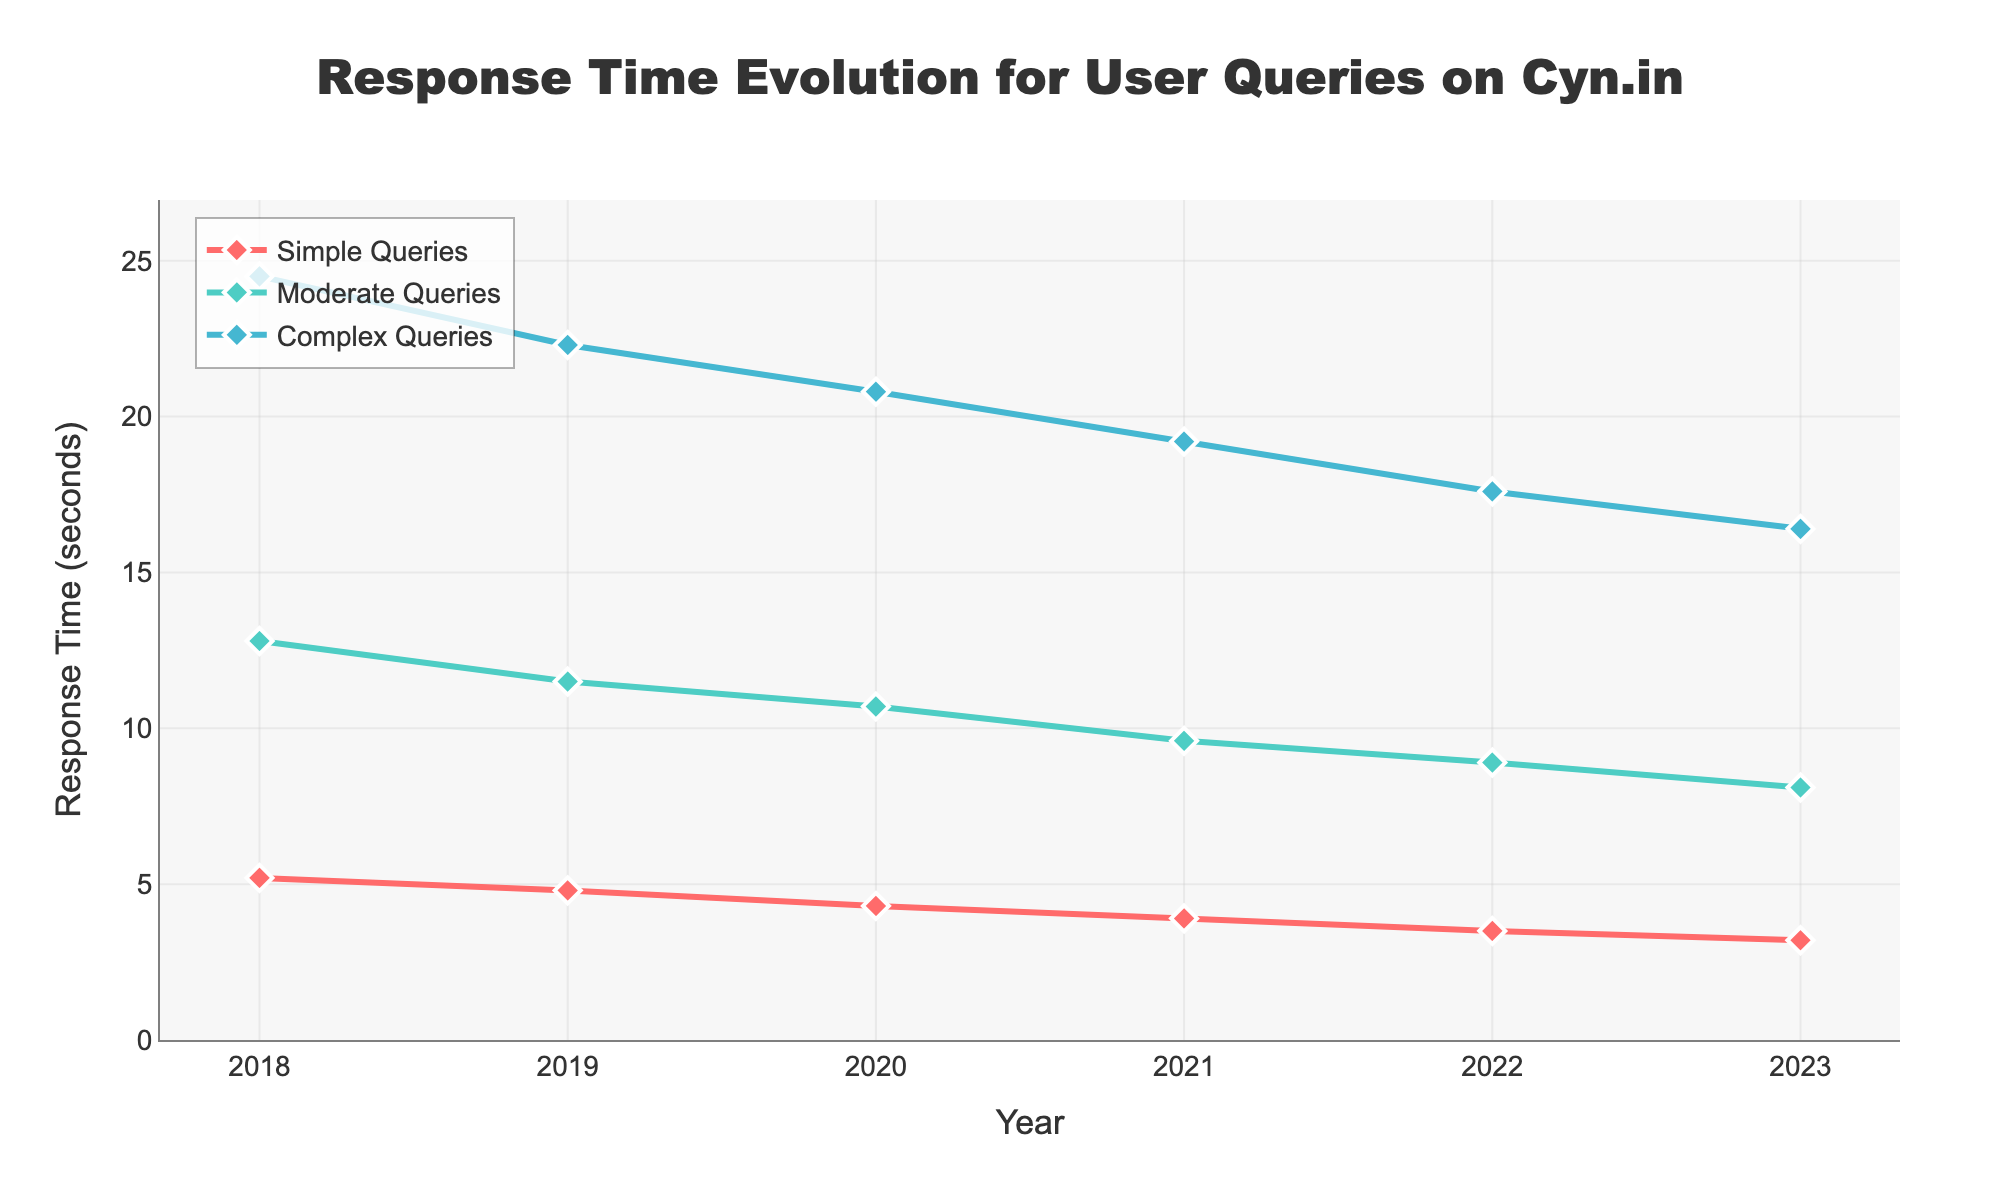What is the trend of response times for simple queries from 2018 to 2023? The response times for simple queries decrease consistently from approximately 5.2 seconds in 2018 to 3.2 seconds in 2023. This indicates an improvement in handling time for simple queries over the years.
Answer: Decreasing What is the percentage decrease in response time for moderate queries from 2018 to 2023? To calculate the percentage decrease: ((12.8 - 8.1) / 12.8) * 100. This gives us ((4.7) / 12.8) * 100 ≈ 36.72%.
Answer: 36.72% How do the response times for complex queries compare between 2018 and 2023? In 2018, the response time for complex queries was 24.5 seconds, whereas in 2023, it is 16.4. Thus, the response time for complex queries has decreased.
Answer: Decrease What is the average response time for moderate queries over the years 2018 and 2023? Average = (Sum of values over years) / number of years. Sum = 12.8 + 11.5 + 10.7 + 9.6 + 8.9 + 8.1 = 61.6; Average = 61.6 / 6 ≈ 10.27.
Answer: 10.27 Which type of query showed the largest absolute improvement in response time from 2018 to 2023? The absolute improvement can be found by subtraction: Simple Queries: 5.2 - 3.2 = 2; Moderate Queries: 12.8 - 8.1 = 4.7; Complex Queries: 24.5 - 16.4 = 8.1. Complex queries showed the largest improvement.
Answer: Complex Queries Between which two consecutive years did simple queries show the greatest reduction in response time? To find the greatest reduction, calculate the difference between consecutive years: (5.2 - 4.8), (4.8 - 4.3), (4.3 - 3.9), (3.9 - 3.5), (3.5 - 3.2): the largest reduction is between 2018 and 2019 with 0.4 seconds.
Answer: 2018 and 2019 What is the difference in response times between moderate and complex queries in 2023? In 2023, the response time for moderate queries is 8.1 seconds, and for complex queries, it is 16.4 seconds. The difference is 16.4 - 8.1 = 8.3 seconds.
Answer: 8.3 seconds Which year exhibits the lowest average response time across all types of queries? Calculate the average response time for each year: 2018: (5.2 + 12.8 + 24.5)/3 = 14.17; 2019: (4.8 + 11.5 + 22.3)/3 = 12.87; 2020: (4.3 + 10.7 + 20.8)/3 = 11.93; 2021: (3.9 + 9.6 + 19.2)/3 = 10.9; 2022: (3.5 + 8.9 + 17.6)/3 = 10; 2023: (3.2 + 8.1 + 16.4)/3 = 9.23. The year 2023 has the lowest average response time at 9.23 seconds.
Answer: 2023 How much has the response time for complex queries improved in total from 2018 to 2023? The improvement can be calculated by subtracting the response time in 2023 from the time in 2018: 24.5 - 16.4 = 8.1.
Answer: 8.1 Which query type had the least year-over-year change in response time between 2020 and 2021? Calculate the year-over-year changes: Simple Queries: 4.3 - 3.9 = 0.4; Moderate Queries: 10.7 - 9.6 = 1.1; Complex Queries: 20.8 - 19.2 = 1.6. Simple queries had the least change with 0.4 seconds.
Answer: Simple Queries 